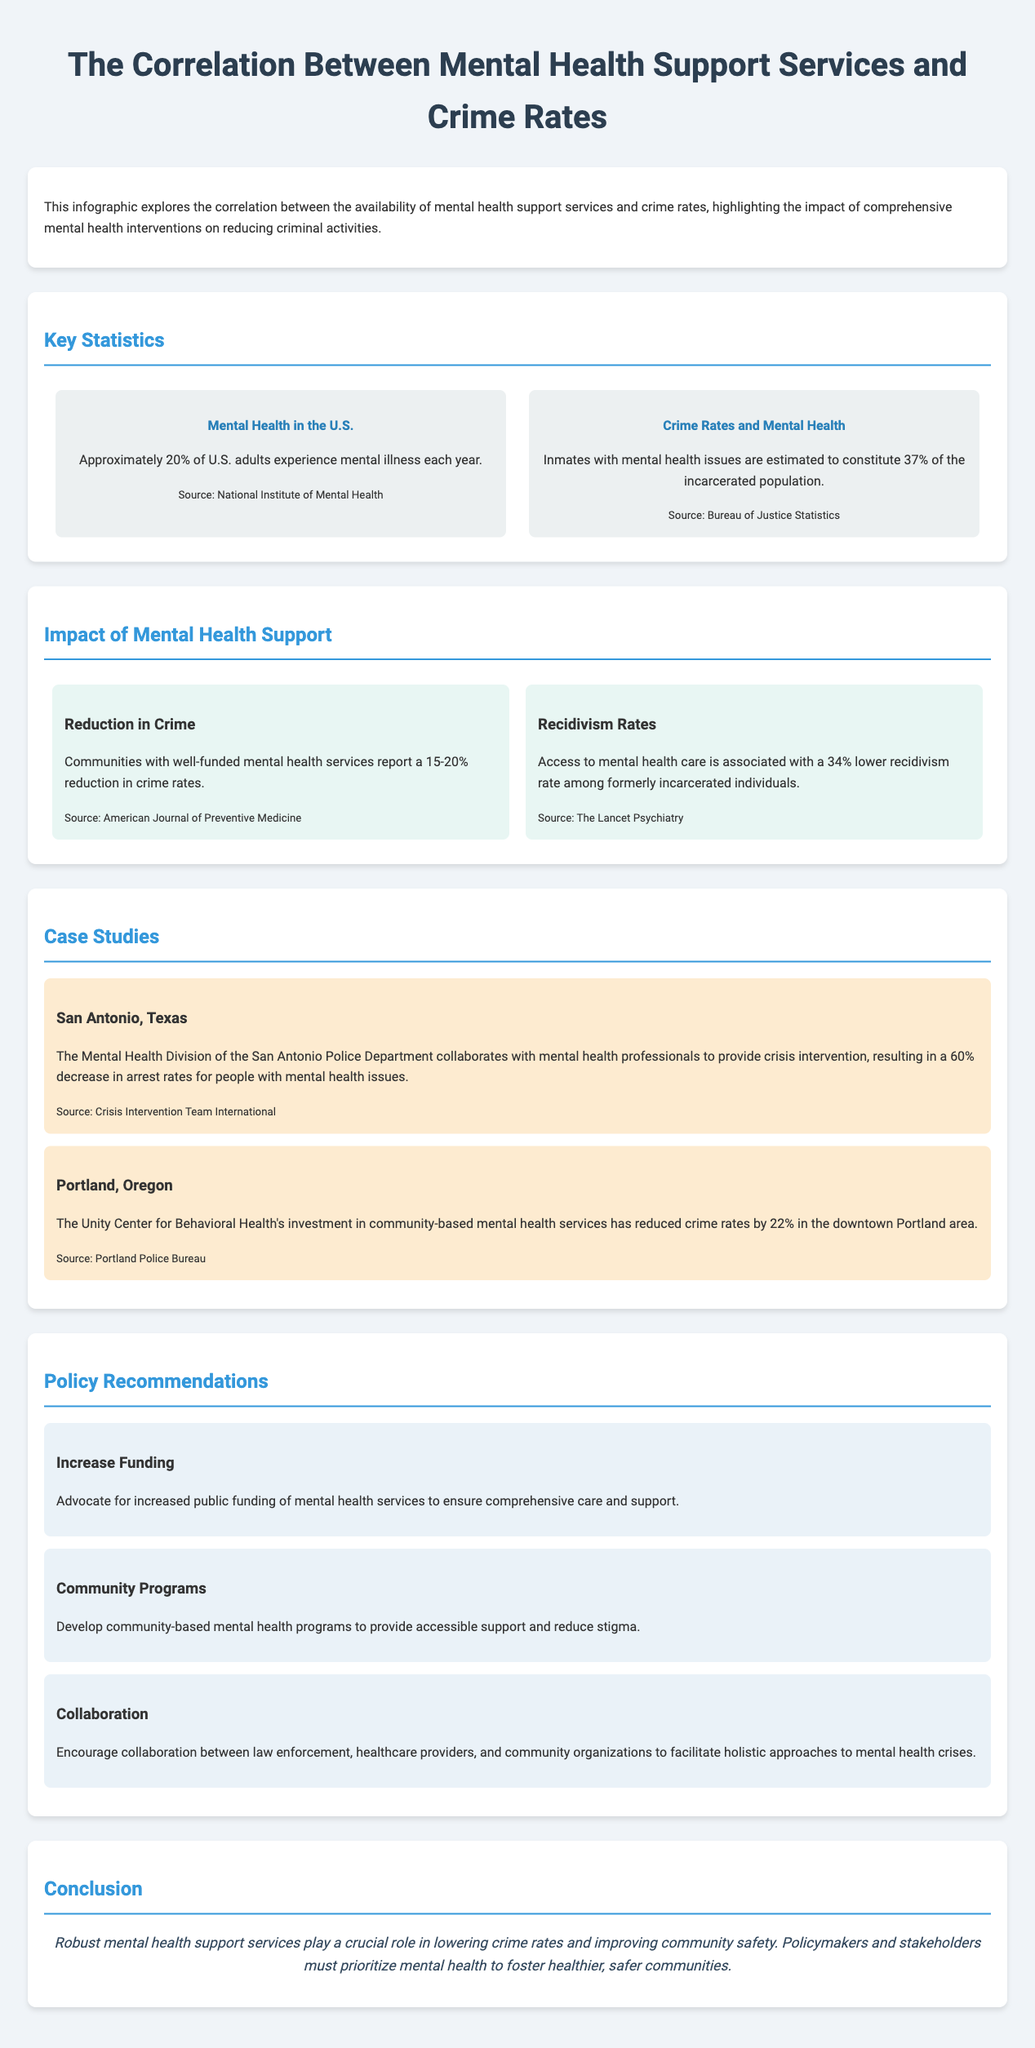what percentage of U.S. adults experience mental illness each year? The document states that approximately 20% of U.S. adults experience mental illness each year.
Answer: 20% what is the estimated percentage of inmates with mental health issues? According to the document, inmates with mental health issues are estimated to constitute 37% of the incarcerated population.
Answer: 37% how much reduction in crime is reported in communities with well-funded mental health services? The infographic mentions a 15-20% reduction in crime rates in those communities.
Answer: 15-20% what is the lower recidivism rate associated with access to mental health care? The document states that access to mental health care is associated with a 34% lower recidivism rate among formerly incarcerated individuals.
Answer: 34% what was the decrease in arrest rates for people with mental health issues in San Antonio, Texas? The report indicates a 60% decrease in arrest rates for people with mental health issues in San Antonio.
Answer: 60% what crime rate reduction was reported in downtown Portland due to the Unity Center for Behavioral Health? The document states that crime rates in downtown Portland were reduced by 22%.
Answer: 22% which organization collaborates with the San Antonio Police Department for crisis intervention? The collaboration is with mental health professionals according to the document.
Answer: mental health professionals what is one of the recommendations for addressing mental health crises? The document recommends increasing public funding of mental health services.
Answer: Increase Funding what is the concluding statement's emphasis in the document? The conclusion emphasizes the crucial role of robust mental health support services in lowering crime rates and improving community safety.
Answer: lowering crime rates and improving community safety 